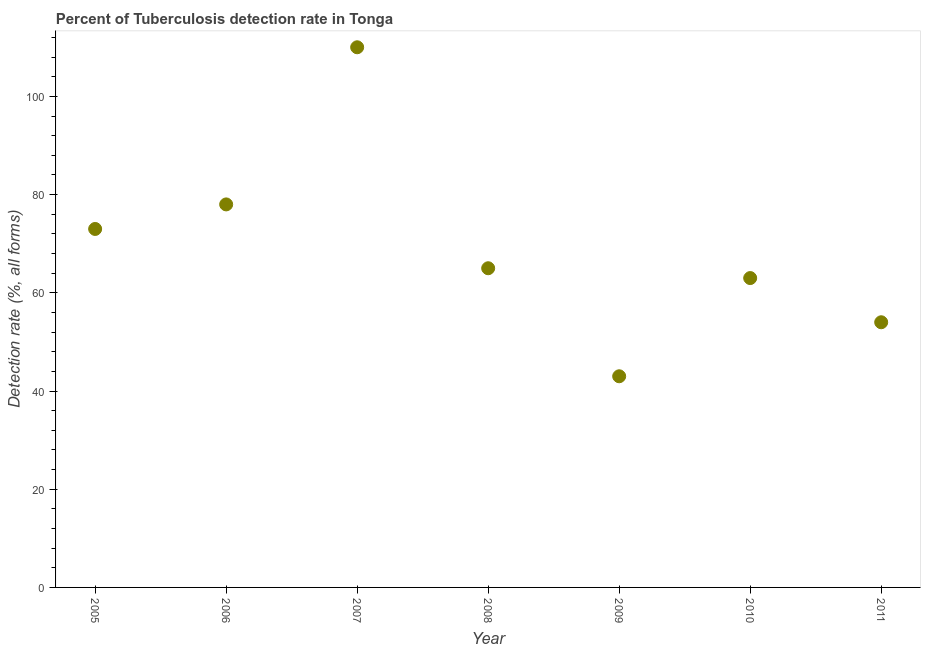What is the detection rate of tuberculosis in 2009?
Your answer should be very brief. 43. Across all years, what is the maximum detection rate of tuberculosis?
Your answer should be compact. 110. Across all years, what is the minimum detection rate of tuberculosis?
Provide a short and direct response. 43. In which year was the detection rate of tuberculosis maximum?
Offer a terse response. 2007. What is the sum of the detection rate of tuberculosis?
Keep it short and to the point. 486. What is the difference between the detection rate of tuberculosis in 2005 and 2011?
Offer a very short reply. 19. What is the average detection rate of tuberculosis per year?
Provide a succinct answer. 69.43. What is the ratio of the detection rate of tuberculosis in 2005 to that in 2006?
Your response must be concise. 0.94. Is the difference between the detection rate of tuberculosis in 2010 and 2011 greater than the difference between any two years?
Provide a succinct answer. No. Is the sum of the detection rate of tuberculosis in 2010 and 2011 greater than the maximum detection rate of tuberculosis across all years?
Keep it short and to the point. Yes. What is the difference between the highest and the lowest detection rate of tuberculosis?
Provide a succinct answer. 67. In how many years, is the detection rate of tuberculosis greater than the average detection rate of tuberculosis taken over all years?
Your response must be concise. 3. Does the detection rate of tuberculosis monotonically increase over the years?
Your answer should be very brief. No. How many dotlines are there?
Offer a very short reply. 1. Does the graph contain any zero values?
Ensure brevity in your answer.  No. What is the title of the graph?
Make the answer very short. Percent of Tuberculosis detection rate in Tonga. What is the label or title of the X-axis?
Your answer should be compact. Year. What is the label or title of the Y-axis?
Ensure brevity in your answer.  Detection rate (%, all forms). What is the Detection rate (%, all forms) in 2005?
Give a very brief answer. 73. What is the Detection rate (%, all forms) in 2006?
Make the answer very short. 78. What is the Detection rate (%, all forms) in 2007?
Your answer should be very brief. 110. What is the Detection rate (%, all forms) in 2008?
Your response must be concise. 65. What is the Detection rate (%, all forms) in 2009?
Provide a succinct answer. 43. What is the difference between the Detection rate (%, all forms) in 2005 and 2007?
Your answer should be very brief. -37. What is the difference between the Detection rate (%, all forms) in 2005 and 2009?
Provide a short and direct response. 30. What is the difference between the Detection rate (%, all forms) in 2005 and 2010?
Keep it short and to the point. 10. What is the difference between the Detection rate (%, all forms) in 2005 and 2011?
Your answer should be very brief. 19. What is the difference between the Detection rate (%, all forms) in 2006 and 2007?
Make the answer very short. -32. What is the difference between the Detection rate (%, all forms) in 2006 and 2011?
Provide a short and direct response. 24. What is the difference between the Detection rate (%, all forms) in 2007 and 2008?
Keep it short and to the point. 45. What is the difference between the Detection rate (%, all forms) in 2008 and 2011?
Provide a short and direct response. 11. What is the difference between the Detection rate (%, all forms) in 2009 and 2010?
Make the answer very short. -20. What is the ratio of the Detection rate (%, all forms) in 2005 to that in 2006?
Provide a succinct answer. 0.94. What is the ratio of the Detection rate (%, all forms) in 2005 to that in 2007?
Offer a very short reply. 0.66. What is the ratio of the Detection rate (%, all forms) in 2005 to that in 2008?
Give a very brief answer. 1.12. What is the ratio of the Detection rate (%, all forms) in 2005 to that in 2009?
Your answer should be compact. 1.7. What is the ratio of the Detection rate (%, all forms) in 2005 to that in 2010?
Provide a succinct answer. 1.16. What is the ratio of the Detection rate (%, all forms) in 2005 to that in 2011?
Give a very brief answer. 1.35. What is the ratio of the Detection rate (%, all forms) in 2006 to that in 2007?
Keep it short and to the point. 0.71. What is the ratio of the Detection rate (%, all forms) in 2006 to that in 2008?
Offer a very short reply. 1.2. What is the ratio of the Detection rate (%, all forms) in 2006 to that in 2009?
Give a very brief answer. 1.81. What is the ratio of the Detection rate (%, all forms) in 2006 to that in 2010?
Your answer should be very brief. 1.24. What is the ratio of the Detection rate (%, all forms) in 2006 to that in 2011?
Your answer should be very brief. 1.44. What is the ratio of the Detection rate (%, all forms) in 2007 to that in 2008?
Offer a very short reply. 1.69. What is the ratio of the Detection rate (%, all forms) in 2007 to that in 2009?
Make the answer very short. 2.56. What is the ratio of the Detection rate (%, all forms) in 2007 to that in 2010?
Ensure brevity in your answer.  1.75. What is the ratio of the Detection rate (%, all forms) in 2007 to that in 2011?
Provide a succinct answer. 2.04. What is the ratio of the Detection rate (%, all forms) in 2008 to that in 2009?
Ensure brevity in your answer.  1.51. What is the ratio of the Detection rate (%, all forms) in 2008 to that in 2010?
Ensure brevity in your answer.  1.03. What is the ratio of the Detection rate (%, all forms) in 2008 to that in 2011?
Your answer should be compact. 1.2. What is the ratio of the Detection rate (%, all forms) in 2009 to that in 2010?
Provide a short and direct response. 0.68. What is the ratio of the Detection rate (%, all forms) in 2009 to that in 2011?
Ensure brevity in your answer.  0.8. What is the ratio of the Detection rate (%, all forms) in 2010 to that in 2011?
Ensure brevity in your answer.  1.17. 